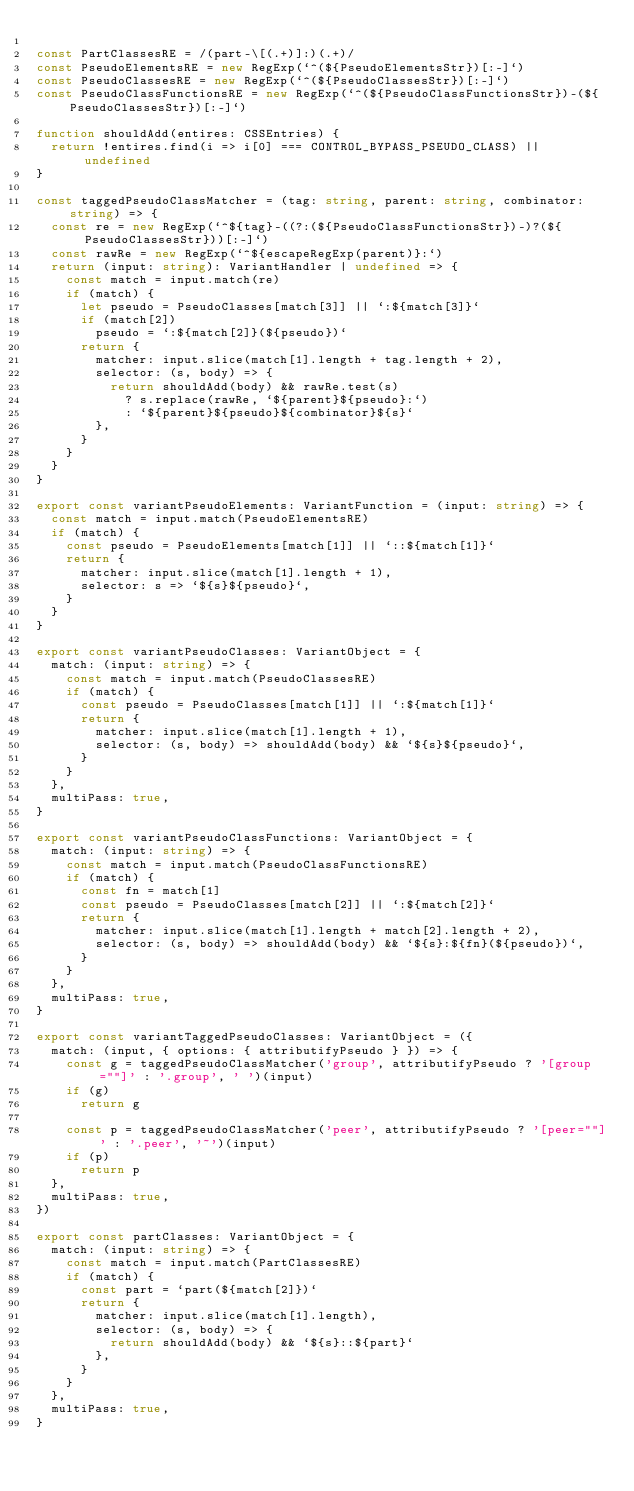Convert code to text. <code><loc_0><loc_0><loc_500><loc_500><_TypeScript_>
const PartClassesRE = /(part-\[(.+)]:)(.+)/
const PseudoElementsRE = new RegExp(`^(${PseudoElementsStr})[:-]`)
const PseudoClassesRE = new RegExp(`^(${PseudoClassesStr})[:-]`)
const PseudoClassFunctionsRE = new RegExp(`^(${PseudoClassFunctionsStr})-(${PseudoClassesStr})[:-]`)

function shouldAdd(entires: CSSEntries) {
  return !entires.find(i => i[0] === CONTROL_BYPASS_PSEUDO_CLASS) || undefined
}

const taggedPseudoClassMatcher = (tag: string, parent: string, combinator: string) => {
  const re = new RegExp(`^${tag}-((?:(${PseudoClassFunctionsStr})-)?(${PseudoClassesStr}))[:-]`)
  const rawRe = new RegExp(`^${escapeRegExp(parent)}:`)
  return (input: string): VariantHandler | undefined => {
    const match = input.match(re)
    if (match) {
      let pseudo = PseudoClasses[match[3]] || `:${match[3]}`
      if (match[2])
        pseudo = `:${match[2]}(${pseudo})`
      return {
        matcher: input.slice(match[1].length + tag.length + 2),
        selector: (s, body) => {
          return shouldAdd(body) && rawRe.test(s)
            ? s.replace(rawRe, `${parent}${pseudo}:`)
            : `${parent}${pseudo}${combinator}${s}`
        },
      }
    }
  }
}

export const variantPseudoElements: VariantFunction = (input: string) => {
  const match = input.match(PseudoElementsRE)
  if (match) {
    const pseudo = PseudoElements[match[1]] || `::${match[1]}`
    return {
      matcher: input.slice(match[1].length + 1),
      selector: s => `${s}${pseudo}`,
    }
  }
}

export const variantPseudoClasses: VariantObject = {
  match: (input: string) => {
    const match = input.match(PseudoClassesRE)
    if (match) {
      const pseudo = PseudoClasses[match[1]] || `:${match[1]}`
      return {
        matcher: input.slice(match[1].length + 1),
        selector: (s, body) => shouldAdd(body) && `${s}${pseudo}`,
      }
    }
  },
  multiPass: true,
}

export const variantPseudoClassFunctions: VariantObject = {
  match: (input: string) => {
    const match = input.match(PseudoClassFunctionsRE)
    if (match) {
      const fn = match[1]
      const pseudo = PseudoClasses[match[2]] || `:${match[2]}`
      return {
        matcher: input.slice(match[1].length + match[2].length + 2),
        selector: (s, body) => shouldAdd(body) && `${s}:${fn}(${pseudo})`,
      }
    }
  },
  multiPass: true,
}

export const variantTaggedPseudoClasses: VariantObject = ({
  match: (input, { options: { attributifyPseudo } }) => {
    const g = taggedPseudoClassMatcher('group', attributifyPseudo ? '[group=""]' : '.group', ' ')(input)
    if (g)
      return g

    const p = taggedPseudoClassMatcher('peer', attributifyPseudo ? '[peer=""]' : '.peer', '~')(input)
    if (p)
      return p
  },
  multiPass: true,
})

export const partClasses: VariantObject = {
  match: (input: string) => {
    const match = input.match(PartClassesRE)
    if (match) {
      const part = `part(${match[2]})`
      return {
        matcher: input.slice(match[1].length),
        selector: (s, body) => {
          return shouldAdd(body) && `${s}::${part}`
        },
      }
    }
  },
  multiPass: true,
}
</code> 